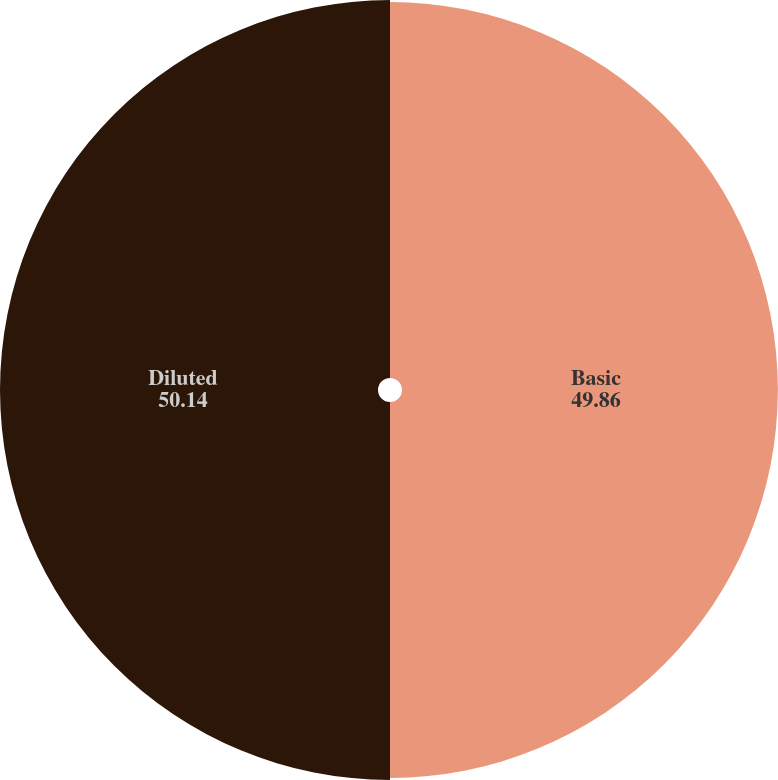Convert chart to OTSL. <chart><loc_0><loc_0><loc_500><loc_500><pie_chart><fcel>Basic<fcel>Diluted<nl><fcel>49.86%<fcel>50.14%<nl></chart> 